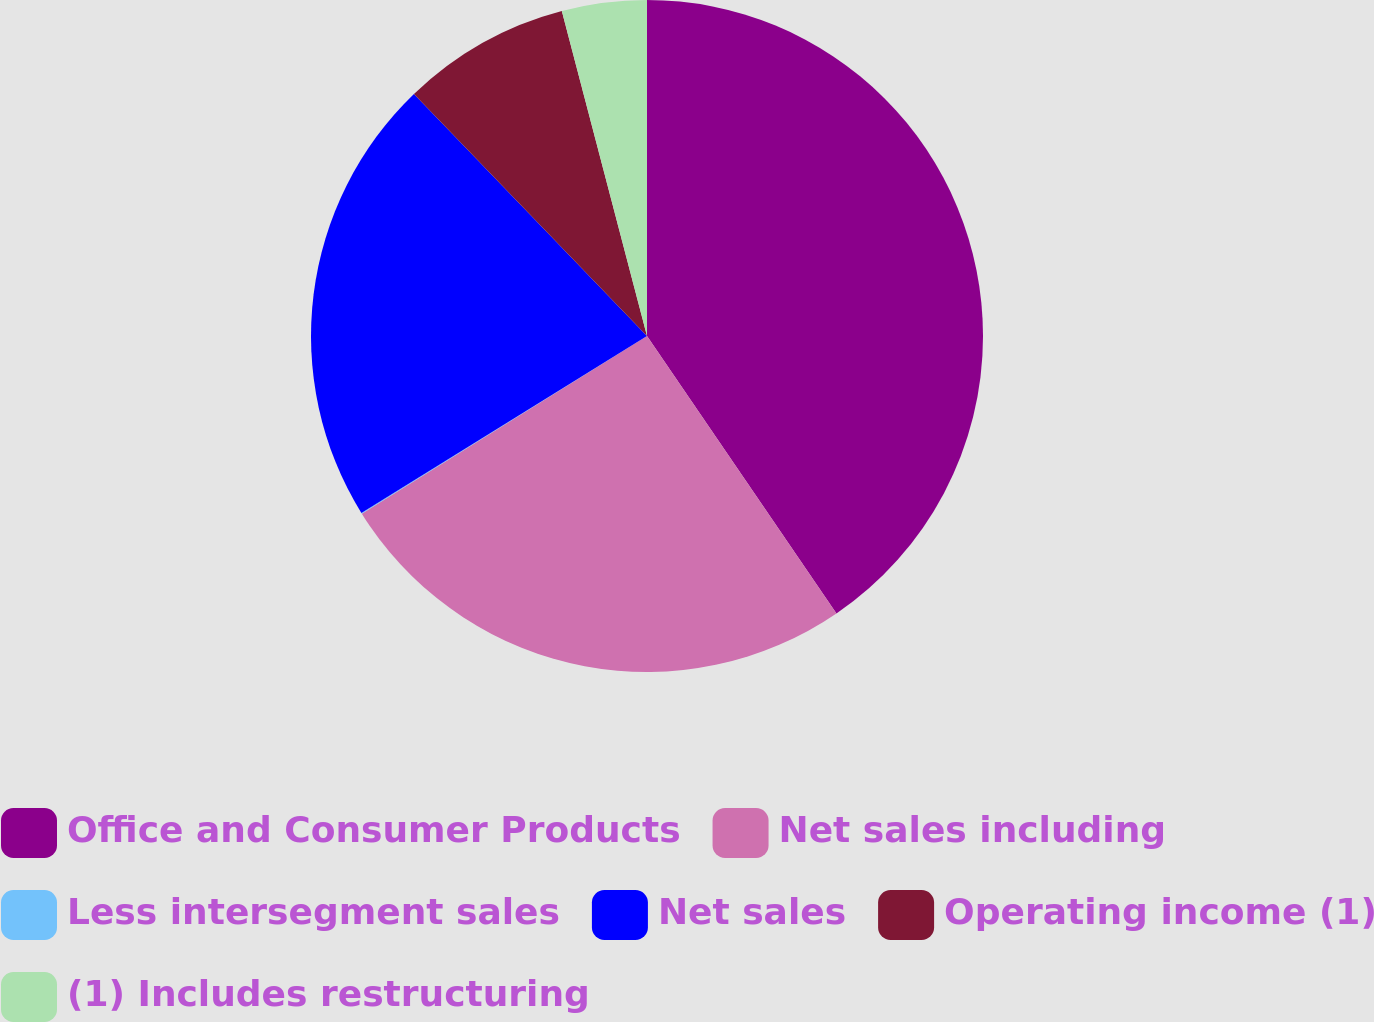Convert chart. <chart><loc_0><loc_0><loc_500><loc_500><pie_chart><fcel>Office and Consumer Products<fcel>Net sales including<fcel>Less intersegment sales<fcel>Net sales<fcel>Operating income (1)<fcel>(1) Includes restructuring<nl><fcel>40.47%<fcel>25.67%<fcel>0.04%<fcel>21.63%<fcel>8.12%<fcel>4.08%<nl></chart> 